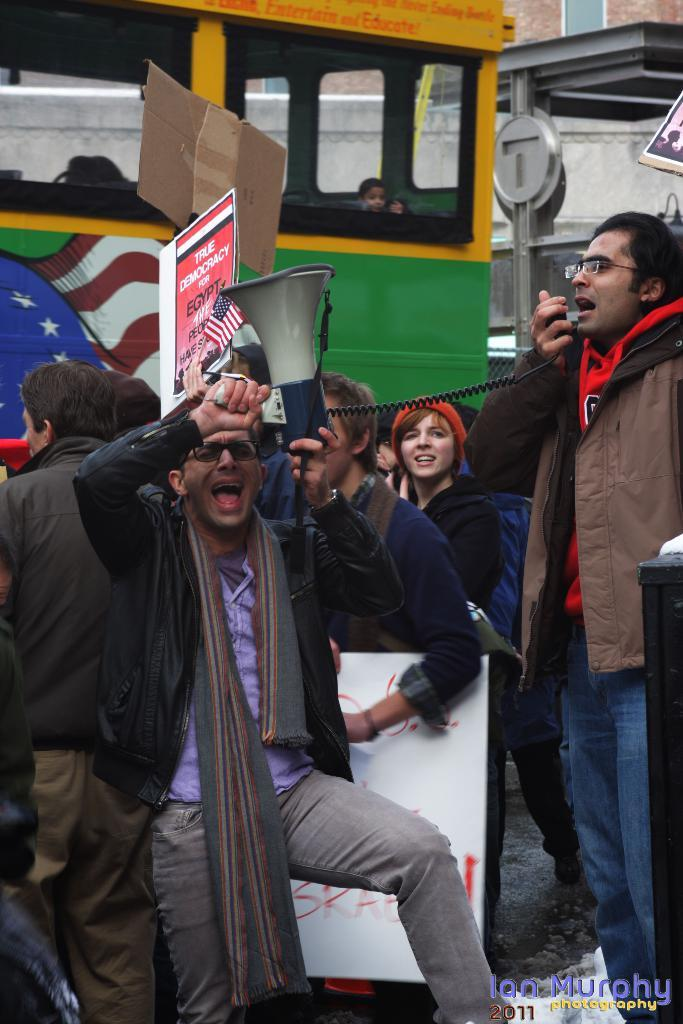What are the people in the image doing? The people in the image are standing, holding banners, speakers, and microphones. What objects are being held by the people in the image? Some people are holding banners, speakers, and microphones. What can be seen in the background of the image? There is a bus and buildings in the background of the image. What type of cushion is being used to amplify the sound in the image? There is no cushion present in the image, and no object is being used to amplify sound. 